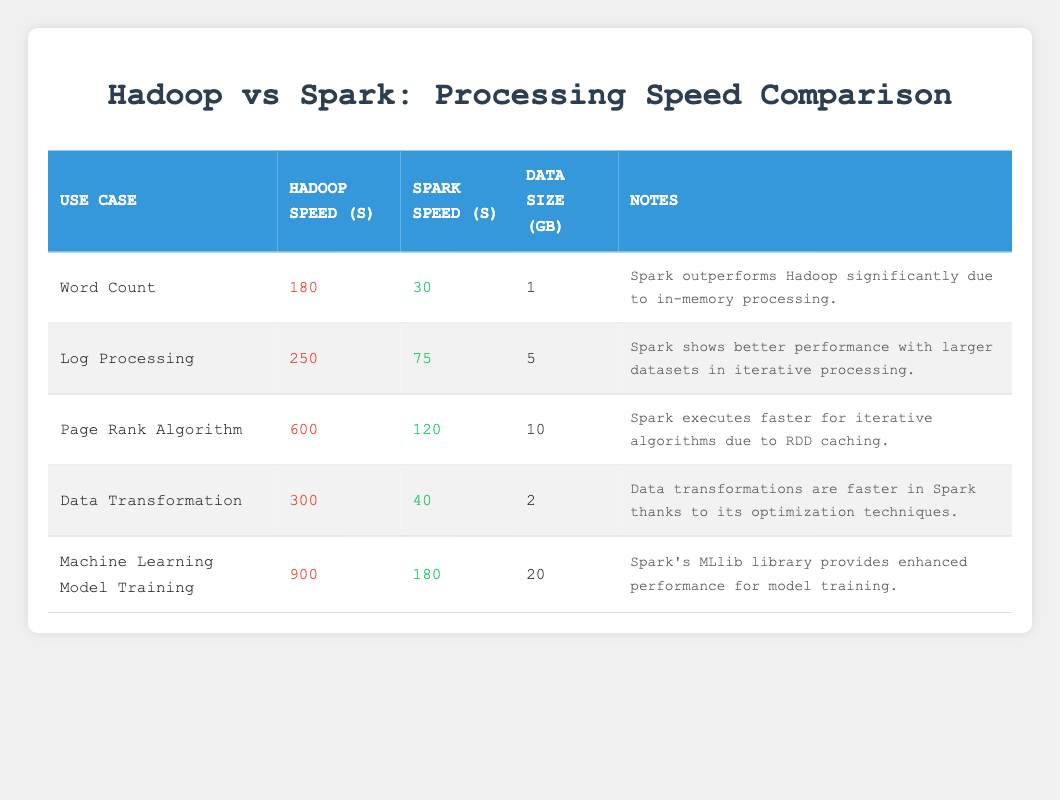What is the speed difference in seconds between Hadoop and Spark for the Word Count use case? The speed for Hadoop in the Word Count use case is 180 seconds, while for Spark it is 30 seconds. To find the difference, we subtract Spark's speed from Hadoop's speed: 180 - 30 = 150 seconds.
Answer: 150 seconds Which use case has the longest processing time with Hadoop? We can compare the Hadoop speeds across all use cases listed in the table. The speeds are: Word Count (180), Log Processing (250), Page Rank Algorithm (600), Data Transformation (300), and Machine Learning Model Training (900). The longest processing time is 900 seconds for Machine Learning Model Training.
Answer: Machine Learning Model Training Does Spark always outperform Hadoop in the tested use cases? Referring to the table, we see that in every use case listed, Spark's speed is lower than Hadoop's speed, indicating that Spark outperforms Hadoop across all scenarios provided.
Answer: Yes What is the average speed of Spark for the use cases listed? To find the average speed for Spark, we first sum the Spark speeds: 30 + 75 + 120 + 40 + 180 = 445 seconds. Then, we divide the total by the number of use cases (5): 445 / 5 = 89 seconds.
Answer: 89 seconds In which use case does Spark achieve the highest processing speed? Looking at the Spark speeds for each use case, we see they are: 30 (Word Count), 75 (Log Processing), 120 (Page Rank Algorithm), 40 (Data Transformation), and 180 (Machine Learning Model Training). The highest processing speed recorded is 180 seconds for Machine Learning Model Training.
Answer: Machine Learning Model Training 